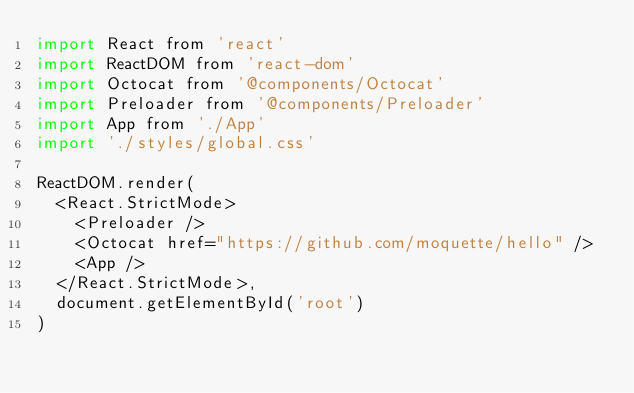<code> <loc_0><loc_0><loc_500><loc_500><_JavaScript_>import React from 'react'
import ReactDOM from 'react-dom'
import Octocat from '@components/Octocat'
import Preloader from '@components/Preloader'
import App from './App'
import './styles/global.css'

ReactDOM.render(
  <React.StrictMode>
    <Preloader />
    <Octocat href="https://github.com/moquette/hello" />
    <App />
  </React.StrictMode>,
  document.getElementById('root')
)
</code> 